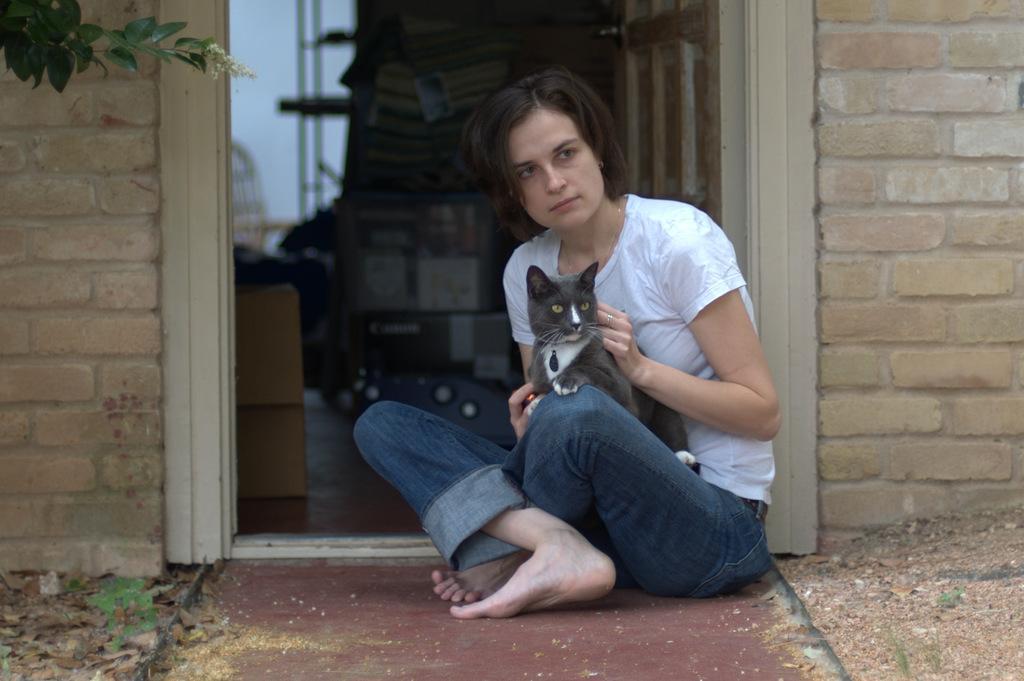Can you describe this image briefly? this picture shows a woman seated on the floor and holding a cat in her hand and we see a house and a tree 